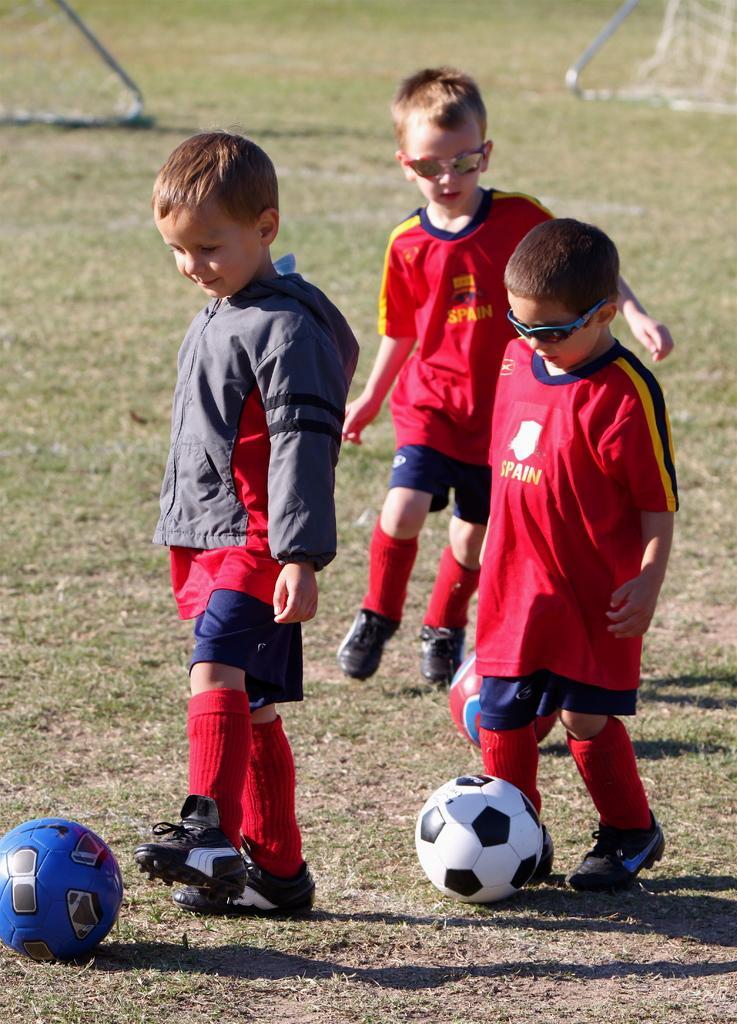Could you give a brief overview of what you see in this image? These 3 boys are playing the foot ball and he is smiling. This is a grass. 